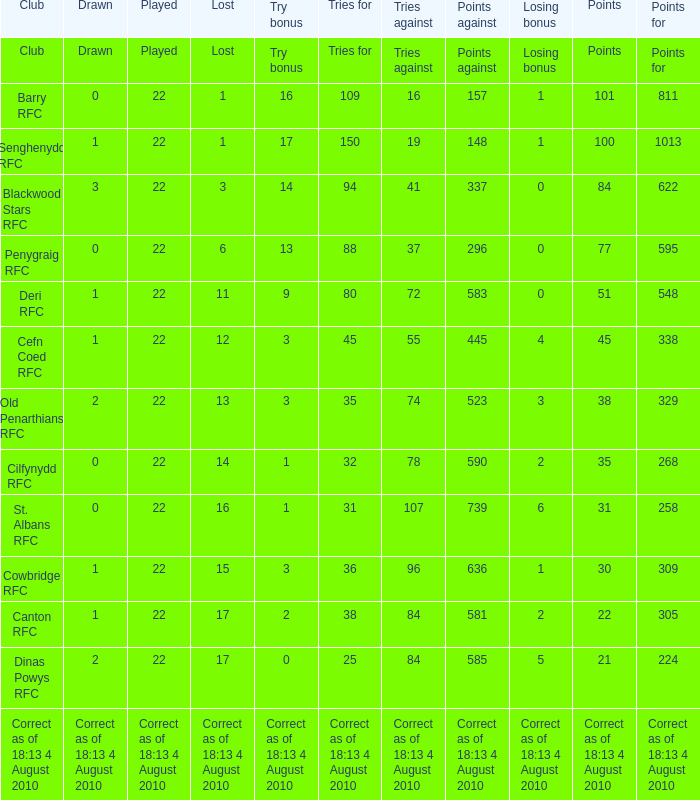What is the played number when tries against is 84, and drawn is 2? 22.0. 